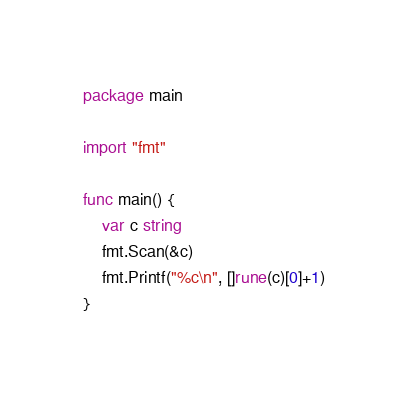Convert code to text. <code><loc_0><loc_0><loc_500><loc_500><_Go_>package main

import "fmt"

func main() {
	var c string
	fmt.Scan(&c)
	fmt.Printf("%c\n", []rune(c)[0]+1)
}</code> 